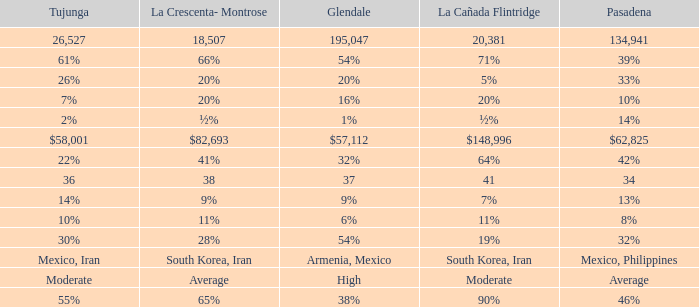Help me parse the entirety of this table. {'header': ['Tujunga', 'La Crescenta- Montrose', 'Glendale', 'La Cañada Flintridge', 'Pasadena'], 'rows': [['26,527', '18,507', '195,047', '20,381', '134,941'], ['61%', '66%', '54%', '71%', '39%'], ['26%', '20%', '20%', '5%', '33%'], ['7%', '20%', '16%', '20%', '10%'], ['2%', '½%', '1%', '½%', '14%'], ['$58,001', '$82,693', '$57,112', '$148,996', '$62,825'], ['22%', '41%', '32%', '64%', '42%'], ['36', '38', '37', '41', '34'], ['14%', '9%', '9%', '7%', '13%'], ['10%', '11%', '6%', '11%', '8%'], ['30%', '28%', '54%', '19%', '32%'], ['Mexico, Iran', 'South Korea, Iran', 'Armenia, Mexico', 'South Korea, Iran', 'Mexico, Philippines'], ['Moderate', 'Average', 'High', 'Moderate', 'Average'], ['55%', '65%', '38%', '90%', '46%']]} When Pasadena is at 10%, what is La Crescenta-Montrose? 20%. 